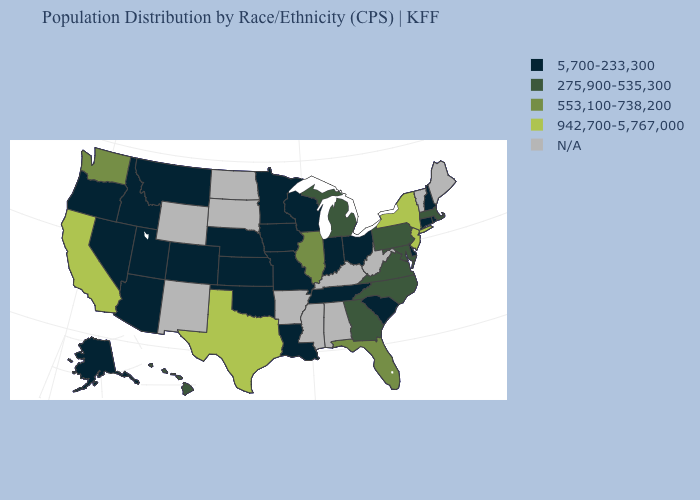What is the value of Idaho?
Short answer required. 5,700-233,300. Name the states that have a value in the range 275,900-535,300?
Answer briefly. Georgia, Hawaii, Maryland, Massachusetts, Michigan, North Carolina, Pennsylvania, Virginia. Which states have the lowest value in the USA?
Short answer required. Alaska, Arizona, Colorado, Connecticut, Delaware, Idaho, Indiana, Iowa, Kansas, Louisiana, Minnesota, Missouri, Montana, Nebraska, Nevada, New Hampshire, Ohio, Oklahoma, Oregon, Rhode Island, South Carolina, Tennessee, Utah, Wisconsin. What is the value of Oregon?
Quick response, please. 5,700-233,300. What is the value of North Dakota?
Answer briefly. N/A. Name the states that have a value in the range 275,900-535,300?
Answer briefly. Georgia, Hawaii, Maryland, Massachusetts, Michigan, North Carolina, Pennsylvania, Virginia. What is the lowest value in the South?
Give a very brief answer. 5,700-233,300. What is the value of Maine?
Answer briefly. N/A. Which states have the lowest value in the USA?
Give a very brief answer. Alaska, Arizona, Colorado, Connecticut, Delaware, Idaho, Indiana, Iowa, Kansas, Louisiana, Minnesota, Missouri, Montana, Nebraska, Nevada, New Hampshire, Ohio, Oklahoma, Oregon, Rhode Island, South Carolina, Tennessee, Utah, Wisconsin. What is the value of Massachusetts?
Keep it brief. 275,900-535,300. Does the first symbol in the legend represent the smallest category?
Answer briefly. Yes. Is the legend a continuous bar?
Short answer required. No. Among the states that border Ohio , does Indiana have the highest value?
Keep it brief. No. Name the states that have a value in the range 5,700-233,300?
Be succinct. Alaska, Arizona, Colorado, Connecticut, Delaware, Idaho, Indiana, Iowa, Kansas, Louisiana, Minnesota, Missouri, Montana, Nebraska, Nevada, New Hampshire, Ohio, Oklahoma, Oregon, Rhode Island, South Carolina, Tennessee, Utah, Wisconsin. 